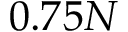Convert formula to latex. <formula><loc_0><loc_0><loc_500><loc_500>0 . 7 5 N</formula> 